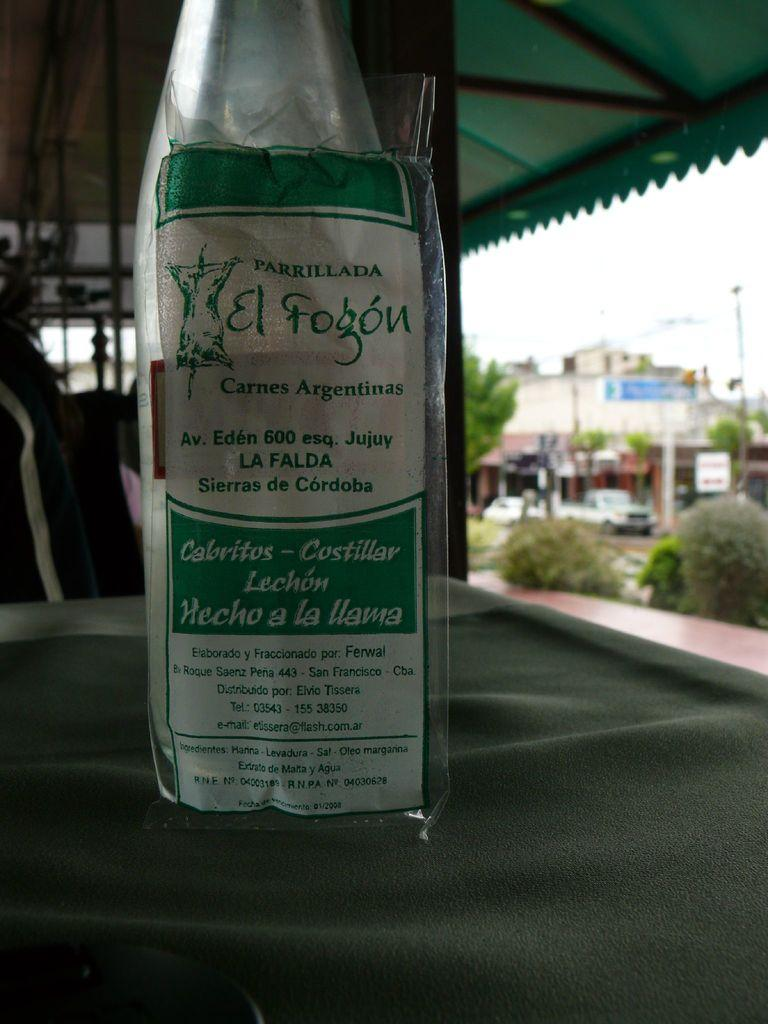<image>
Provide a brief description of the given image. A bottle with a green and white label that says Parrillada on it. 